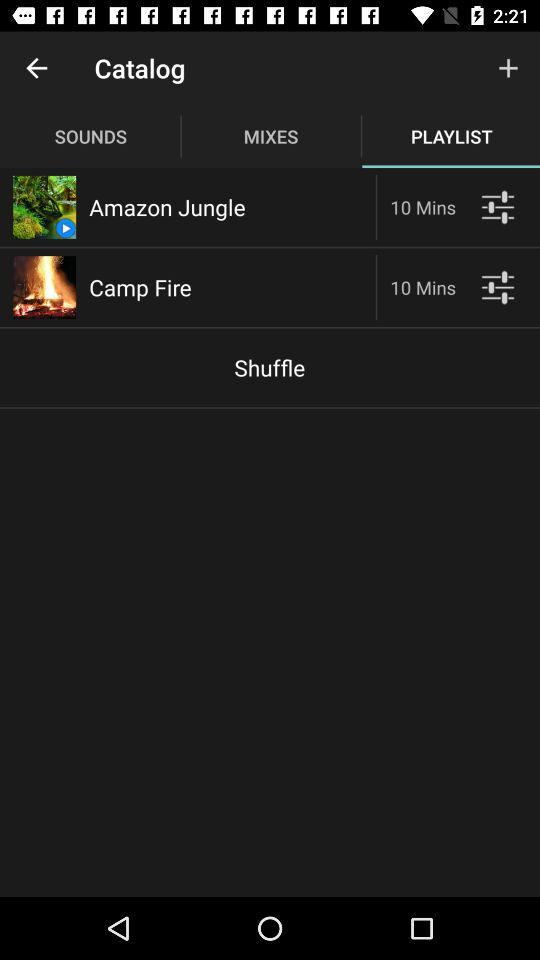What is the duration of the "Camp Fire" video? The duration is 10 minutes. 